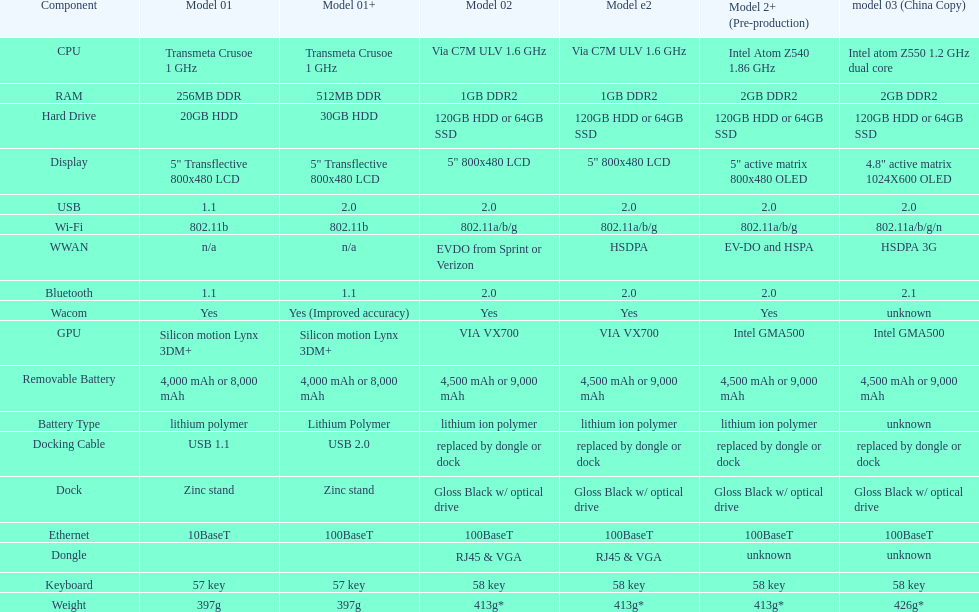How much more weight does the model 3 have over model 1? 29g. 